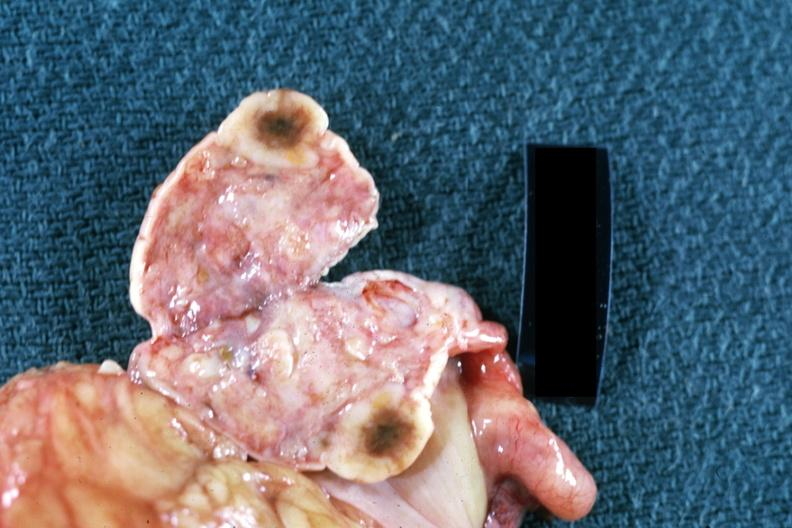does this image show cut surface of ovary close up breast primary?
Answer the question using a single word or phrase. Yes 